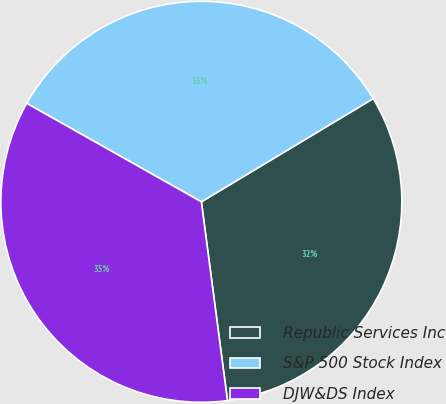<chart> <loc_0><loc_0><loc_500><loc_500><pie_chart><fcel>Republic Services Inc<fcel>S&P 500 Stock Index<fcel>DJW&DS Index<nl><fcel>31.53%<fcel>33.22%<fcel>35.25%<nl></chart> 